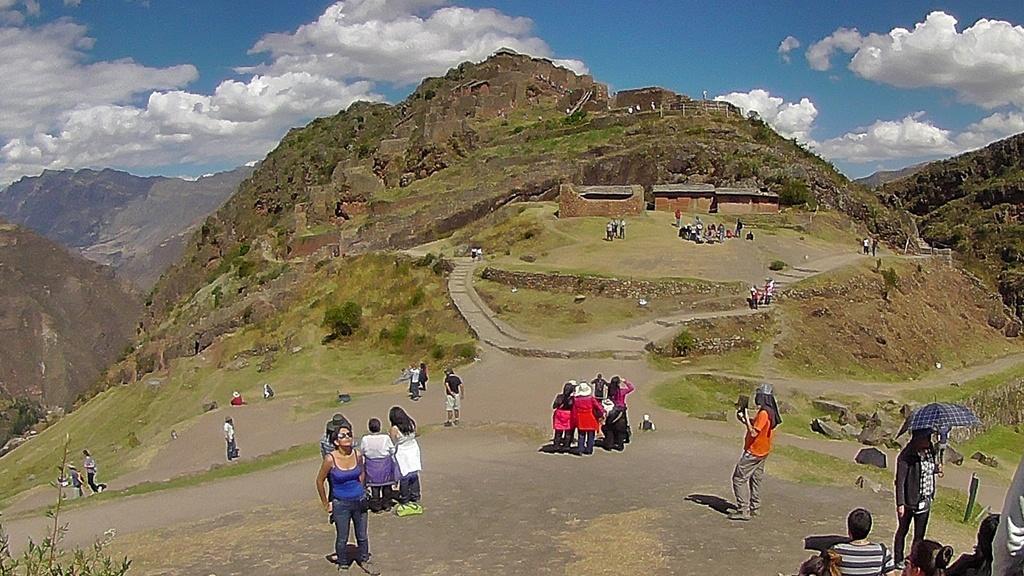Describe this image in one or two sentences. In this image, we can see persons wearing clothes. There are hills in the middle of the image. There is a person in the bottom right of the image holding an umbrella. There are clouds in the sky. 